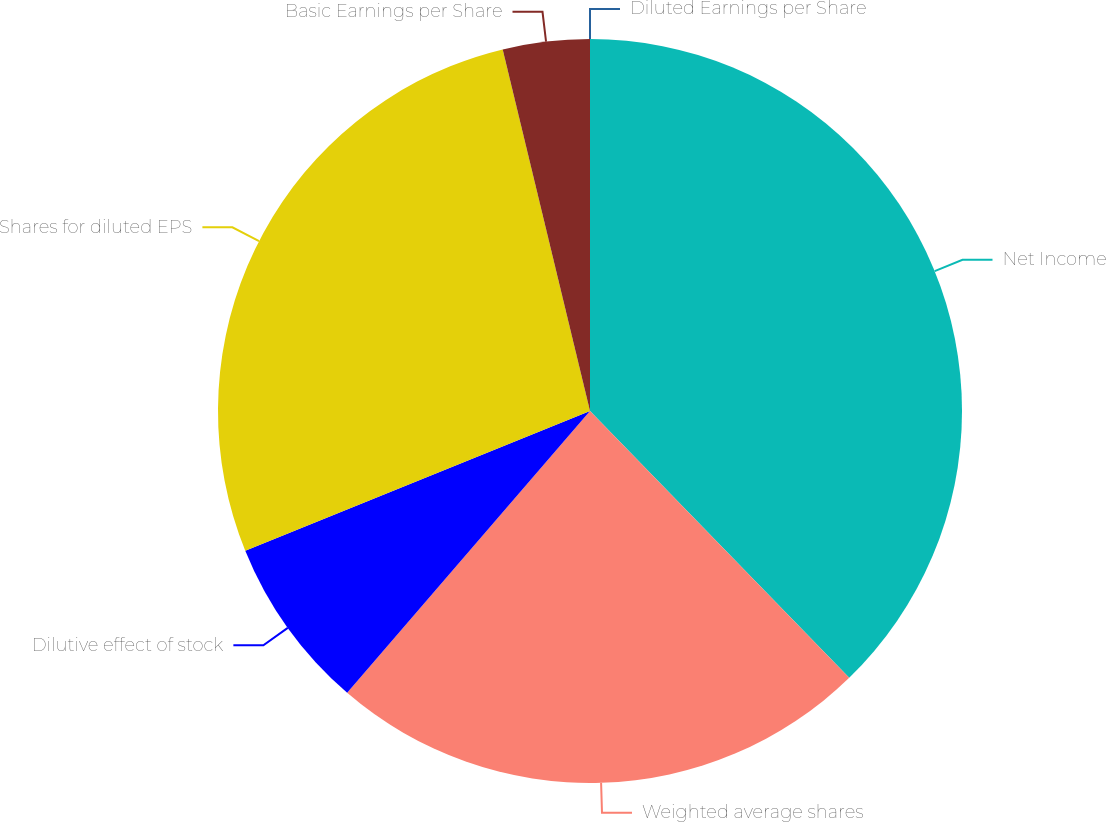Convert chart. <chart><loc_0><loc_0><loc_500><loc_500><pie_chart><fcel>Net Income<fcel>Weighted average shares<fcel>Dilutive effect of stock<fcel>Shares for diluted EPS<fcel>Basic Earnings per Share<fcel>Diluted Earnings per Share<nl><fcel>37.73%<fcel>23.59%<fcel>7.55%<fcel>27.36%<fcel>3.77%<fcel>0.0%<nl></chart> 